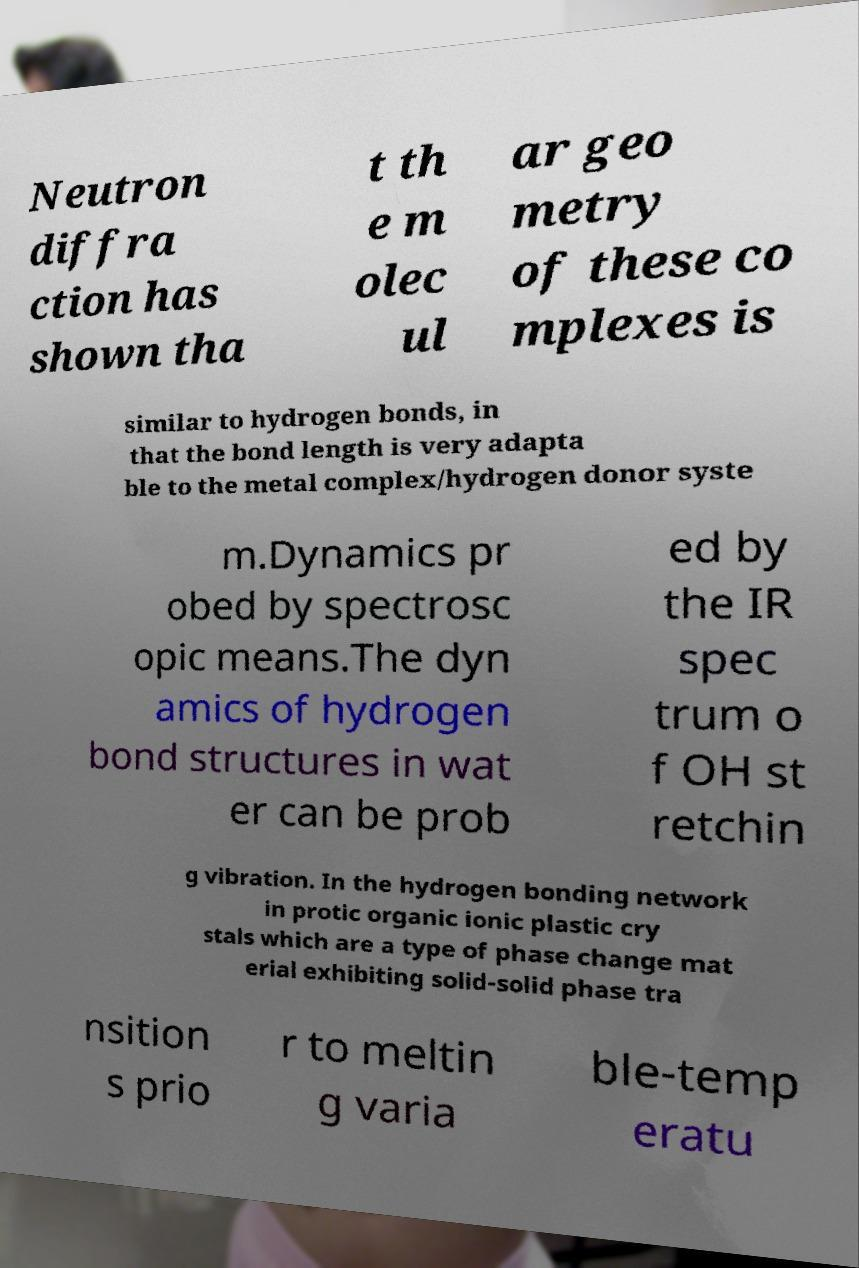I need the written content from this picture converted into text. Can you do that? Neutron diffra ction has shown tha t th e m olec ul ar geo metry of these co mplexes is similar to hydrogen bonds, in that the bond length is very adapta ble to the metal complex/hydrogen donor syste m.Dynamics pr obed by spectrosc opic means.The dyn amics of hydrogen bond structures in wat er can be prob ed by the IR spec trum o f OH st retchin g vibration. In the hydrogen bonding network in protic organic ionic plastic cry stals which are a type of phase change mat erial exhibiting solid-solid phase tra nsition s prio r to meltin g varia ble-temp eratu 